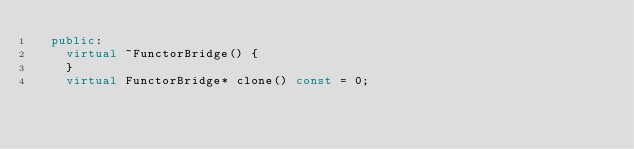<code> <loc_0><loc_0><loc_500><loc_500><_C++_>  public:
    virtual ~FunctorBridge() {
    }
    virtual FunctorBridge* clone() const = 0;</code> 